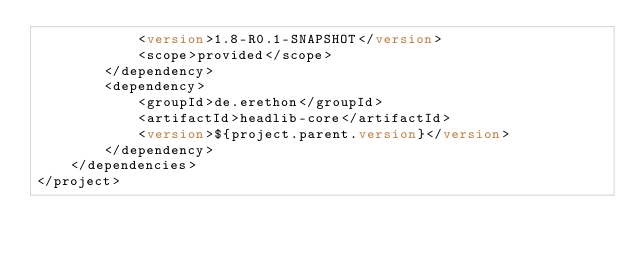<code> <loc_0><loc_0><loc_500><loc_500><_XML_>            <version>1.8-R0.1-SNAPSHOT</version>
            <scope>provided</scope>
        </dependency>
        <dependency>
            <groupId>de.erethon</groupId>
            <artifactId>headlib-core</artifactId>
            <version>${project.parent.version}</version>
        </dependency>
    </dependencies>
</project>
</code> 